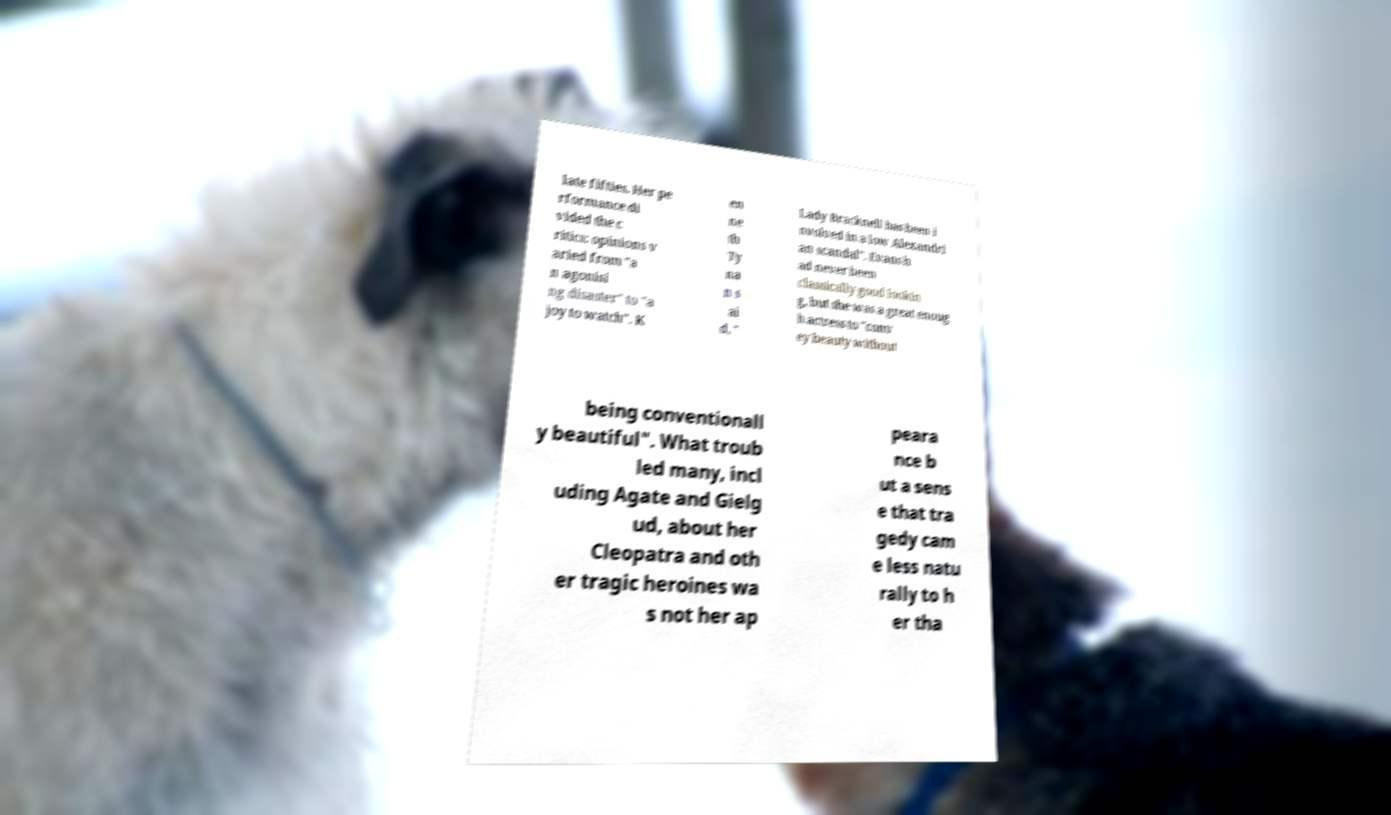Can you read and provide the text displayed in the image?This photo seems to have some interesting text. Can you extract and type it out for me? late fifties. Her pe rformance di vided the c ritics: opinions v aried from "a n agonisi ng disaster" to "a joy to watch". K en ne th Ty na n s ai d, " Lady Bracknell has been i nvolved in a low Alexandri an scandal". Evans h ad never been classically good lookin g, but she was a great enoug h actress to "conv ey beauty without being conventionall y beautiful". What troub led many, incl uding Agate and Gielg ud, about her Cleopatra and oth er tragic heroines wa s not her ap peara nce b ut a sens e that tra gedy cam e less natu rally to h er tha 